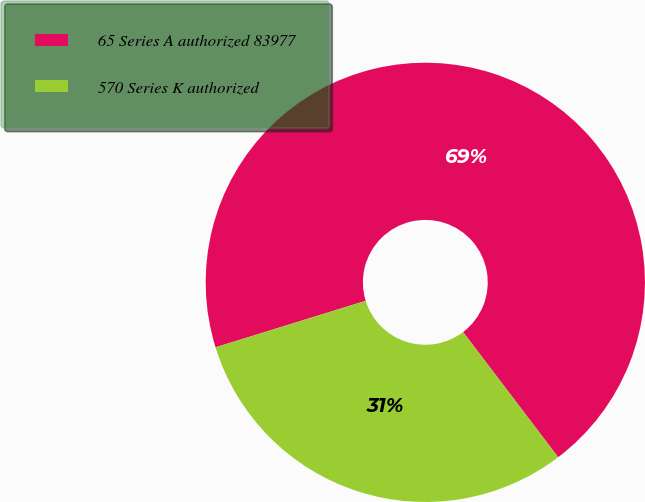Convert chart. <chart><loc_0><loc_0><loc_500><loc_500><pie_chart><fcel>65 Series A authorized 83977<fcel>570 Series K authorized<nl><fcel>69.44%<fcel>30.56%<nl></chart> 